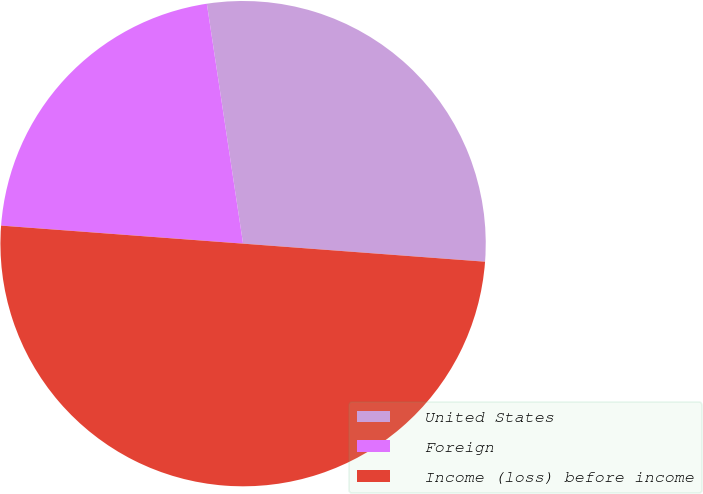Convert chart to OTSL. <chart><loc_0><loc_0><loc_500><loc_500><pie_chart><fcel>United States<fcel>Foreign<fcel>Income (loss) before income<nl><fcel>28.57%<fcel>21.43%<fcel>50.0%<nl></chart> 